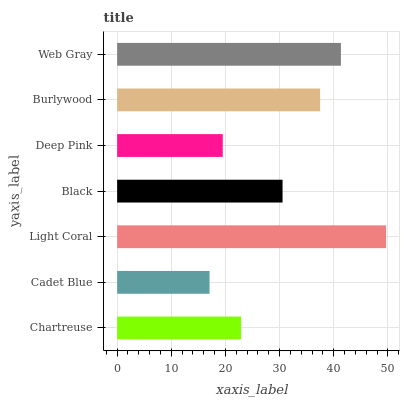Is Cadet Blue the minimum?
Answer yes or no. Yes. Is Light Coral the maximum?
Answer yes or no. Yes. Is Light Coral the minimum?
Answer yes or no. No. Is Cadet Blue the maximum?
Answer yes or no. No. Is Light Coral greater than Cadet Blue?
Answer yes or no. Yes. Is Cadet Blue less than Light Coral?
Answer yes or no. Yes. Is Cadet Blue greater than Light Coral?
Answer yes or no. No. Is Light Coral less than Cadet Blue?
Answer yes or no. No. Is Black the high median?
Answer yes or no. Yes. Is Black the low median?
Answer yes or no. Yes. Is Chartreuse the high median?
Answer yes or no. No. Is Web Gray the low median?
Answer yes or no. No. 